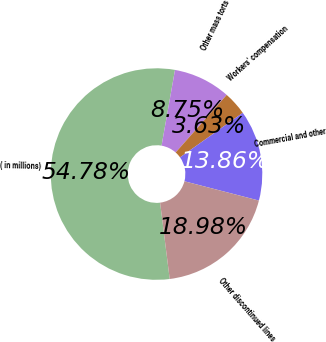<chart> <loc_0><loc_0><loc_500><loc_500><pie_chart><fcel>( in millions)<fcel>Other mass torts<fcel>Workers' compensation<fcel>Commercial and other<fcel>Other discontinued lines<nl><fcel>54.79%<fcel>8.75%<fcel>3.63%<fcel>13.86%<fcel>18.98%<nl></chart> 